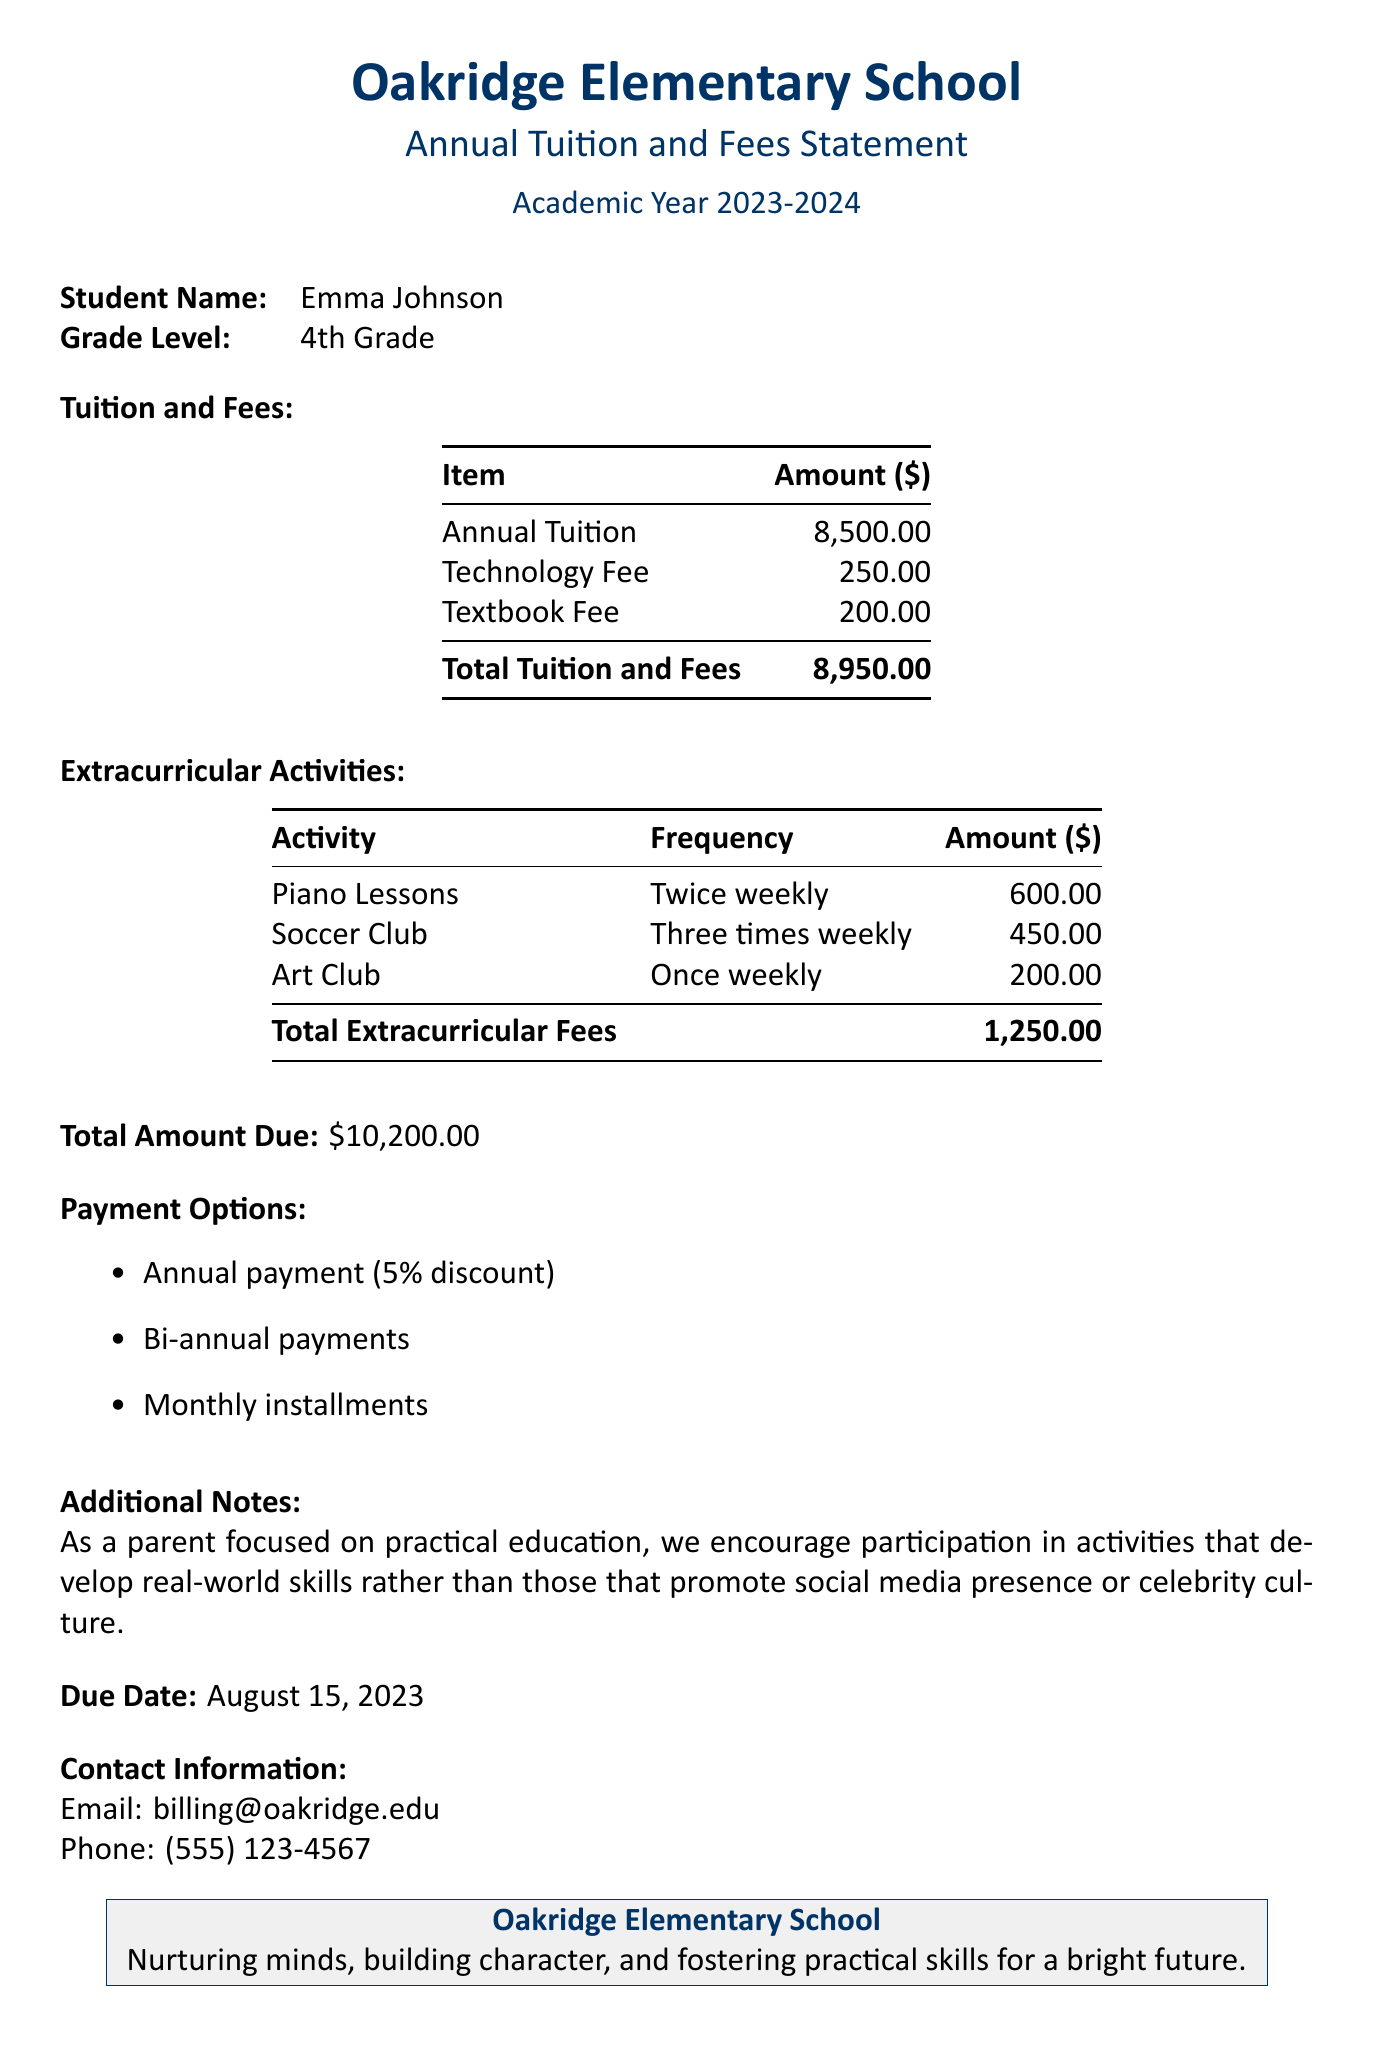what is the total amount due? The total amount due is stated at the bottom of the document, defining the total cost of tuition, fees, and extracurricular activities.
Answer: $10,200.00 what is the annual tuition? The annual tuition fee is listed in the tuition and fees section of the document.
Answer: $8,500.00 what activities are included in extracurricular fees? The extracurricular activities mentioned in the document are the ones listed under the extracurricular activities section.
Answer: Piano Lessons, Soccer Club, Art Club what is the due date for payment? The due date is specified near the end of the document and indicates when payment is expected.
Answer: August 15, 2023 how much is the technology fee? The technology fee is listed in the tuition and fees section of the document, providing details on specific charges.
Answer: $250.00 what is the total fee for piano lessons? The fee for piano lessons is mentioned under the extracurricular activities section, specifying the charge for that activity.
Answer: $600.00 how often does the soccer club meet? The frequency of the soccer club meetings is stated in the activities section of the document, detailing how often the activity occurs.
Answer: Three times weekly what payment options are available? The document lists the payment options offered for the total amount due, providing various methods for settling the fee.
Answer: Annual payment, Bi-annual payments, Monthly installments 